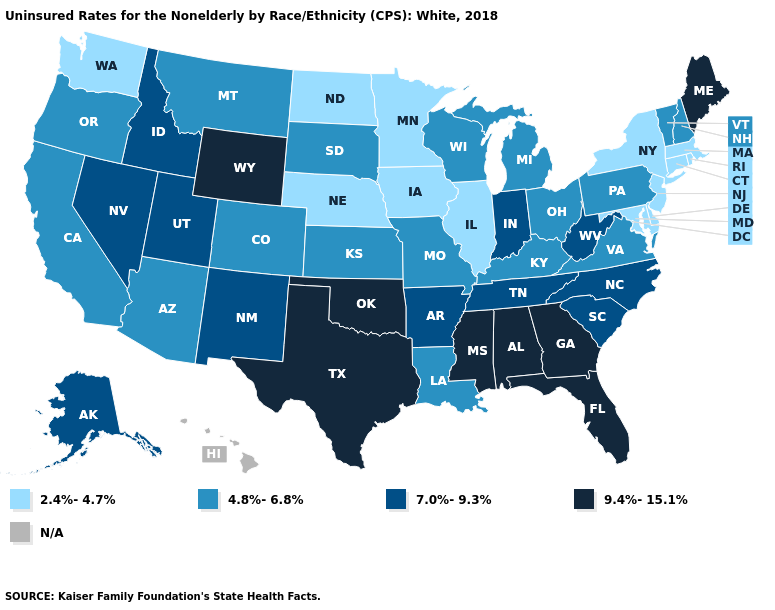What is the highest value in the USA?
Be succinct. 9.4%-15.1%. Name the states that have a value in the range 9.4%-15.1%?
Write a very short answer. Alabama, Florida, Georgia, Maine, Mississippi, Oklahoma, Texas, Wyoming. What is the lowest value in the USA?
Write a very short answer. 2.4%-4.7%. Name the states that have a value in the range 4.8%-6.8%?
Concise answer only. Arizona, California, Colorado, Kansas, Kentucky, Louisiana, Michigan, Missouri, Montana, New Hampshire, Ohio, Oregon, Pennsylvania, South Dakota, Vermont, Virginia, Wisconsin. Name the states that have a value in the range 7.0%-9.3%?
Quick response, please. Alaska, Arkansas, Idaho, Indiana, Nevada, New Mexico, North Carolina, South Carolina, Tennessee, Utah, West Virginia. What is the lowest value in the West?
Answer briefly. 2.4%-4.7%. Does the map have missing data?
Concise answer only. Yes. What is the lowest value in the USA?
Give a very brief answer. 2.4%-4.7%. Name the states that have a value in the range 7.0%-9.3%?
Quick response, please. Alaska, Arkansas, Idaho, Indiana, Nevada, New Mexico, North Carolina, South Carolina, Tennessee, Utah, West Virginia. Does Minnesota have the lowest value in the MidWest?
Answer briefly. Yes. Name the states that have a value in the range N/A?
Answer briefly. Hawaii. What is the value of Indiana?
Keep it brief. 7.0%-9.3%. What is the lowest value in states that border Florida?
Keep it brief. 9.4%-15.1%. Does the map have missing data?
Keep it brief. Yes. 